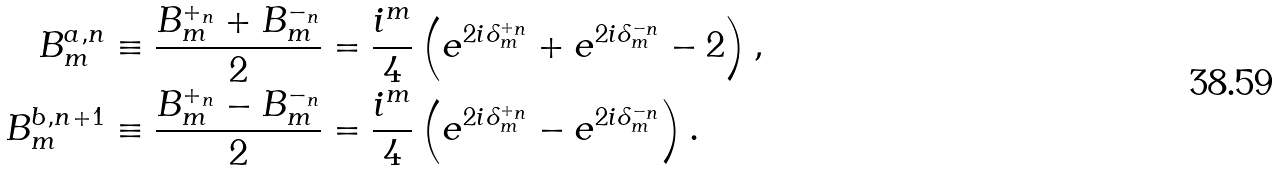Convert formula to latex. <formula><loc_0><loc_0><loc_500><loc_500>B ^ { a , n } _ { m } & \equiv \frac { B ^ { + _ { n } } _ { m } + B ^ { - _ { n } } _ { m } } { 2 } = \frac { i ^ { m } } { 4 } \left ( e ^ { 2 i \delta _ { m } ^ { + _ { n } } } + e ^ { 2 i \delta _ { m } ^ { - _ { n } } } - 2 \right ) , \\ B ^ { b , n + 1 } _ { m } & \equiv \frac { B ^ { + _ { n } } _ { m } - B ^ { - _ { n } } _ { m } } { 2 } = \frac { i ^ { m } } { 4 } \left ( e ^ { 2 i \delta _ { m } ^ { + _ { n } } } - e ^ { 2 i \delta _ { m } ^ { - _ { n } } } \right ) .</formula> 